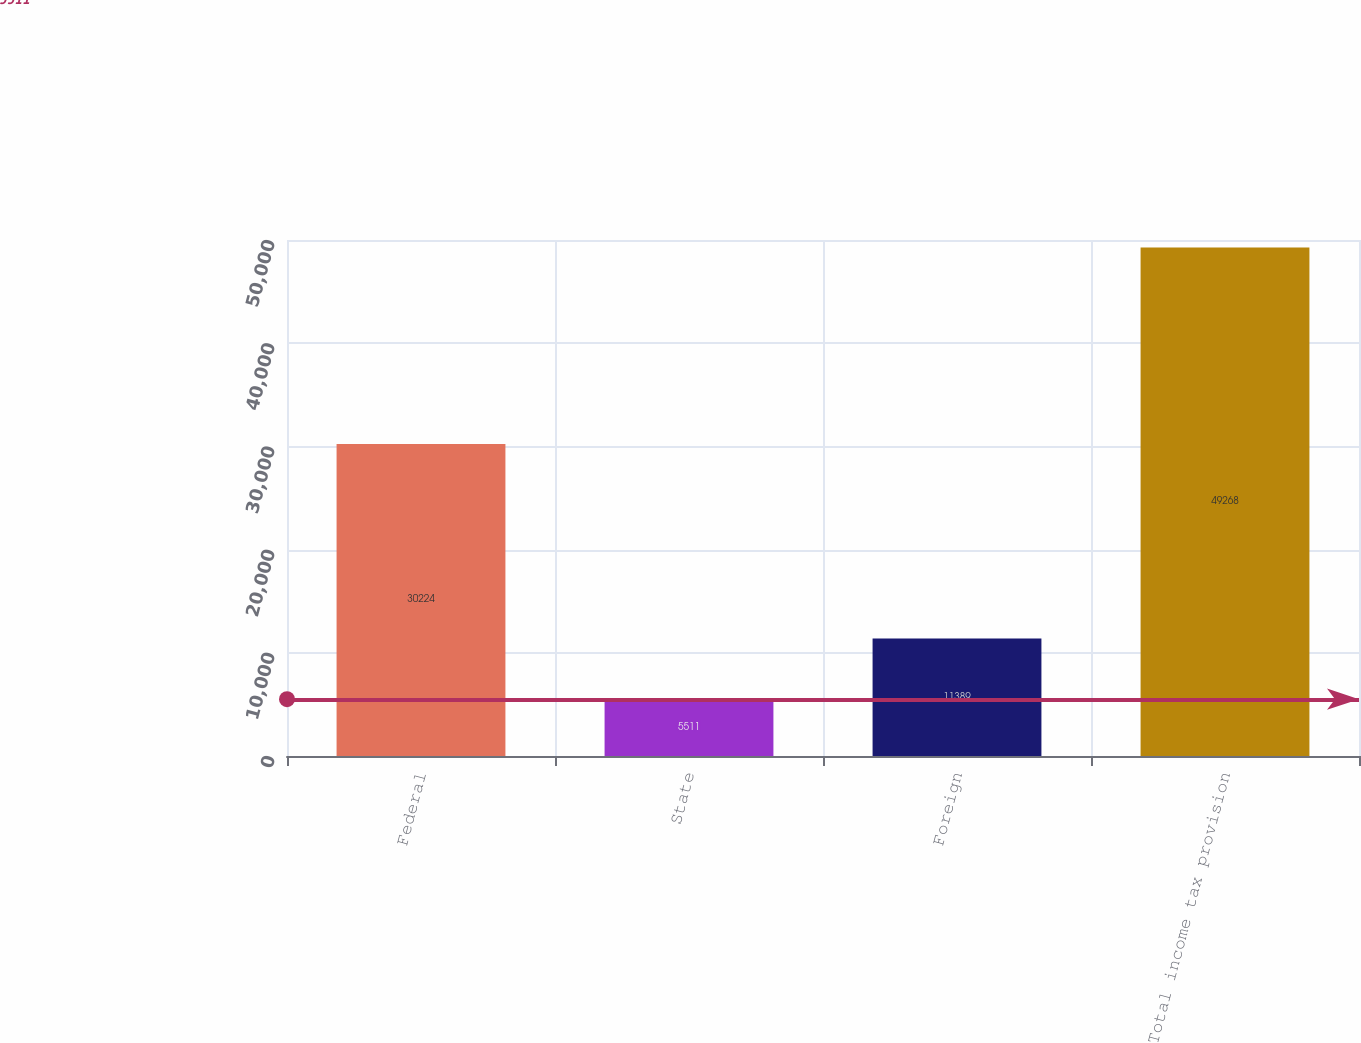Convert chart to OTSL. <chart><loc_0><loc_0><loc_500><loc_500><bar_chart><fcel>Federal<fcel>State<fcel>Foreign<fcel>Total income tax provision<nl><fcel>30224<fcel>5511<fcel>11389<fcel>49268<nl></chart> 